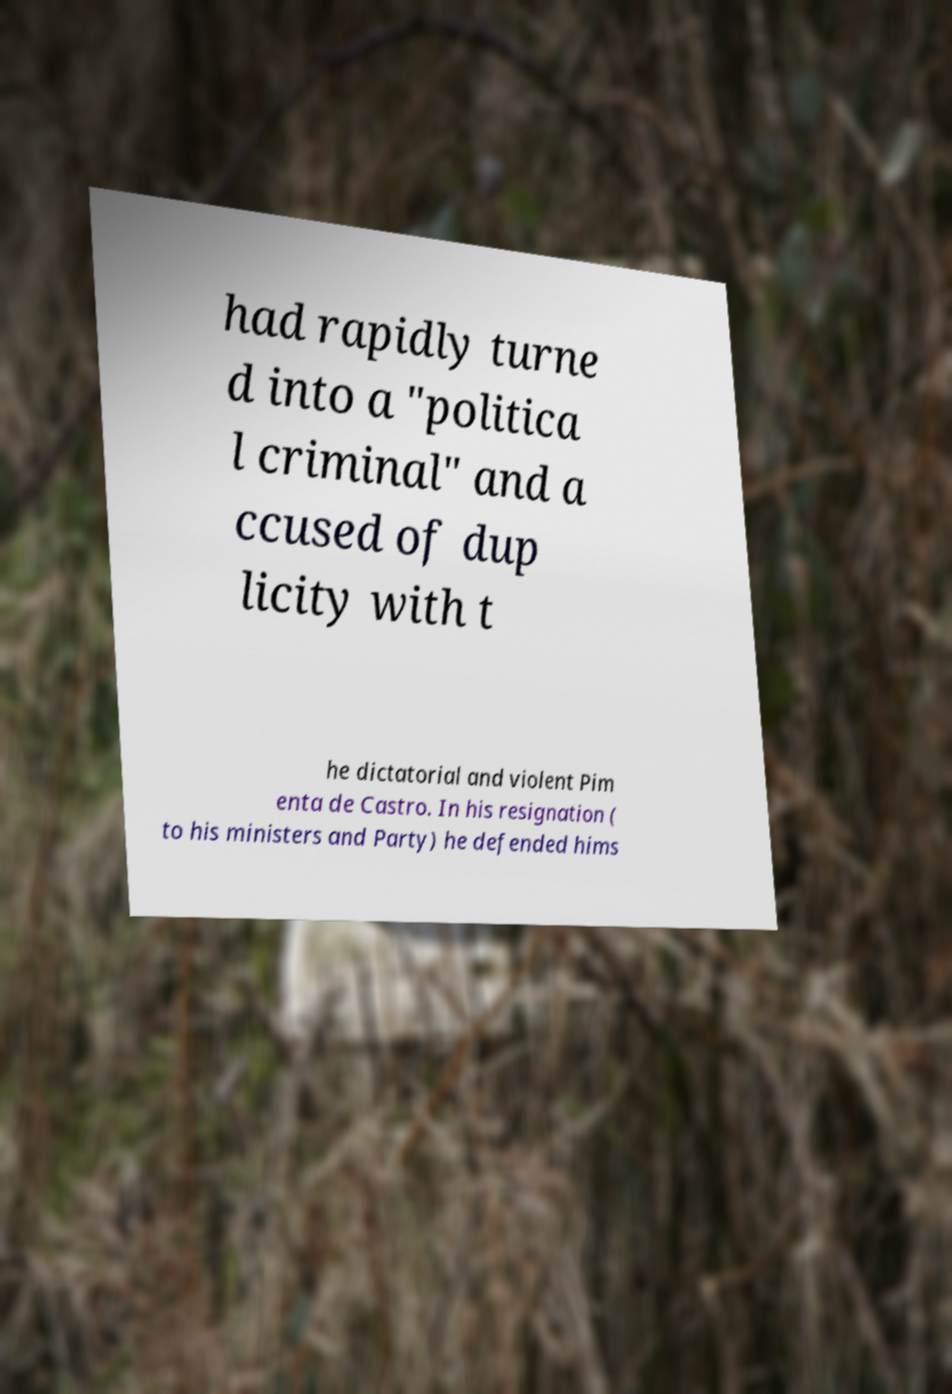I need the written content from this picture converted into text. Can you do that? had rapidly turne d into a "politica l criminal" and a ccused of dup licity with t he dictatorial and violent Pim enta de Castro. In his resignation ( to his ministers and Party) he defended hims 